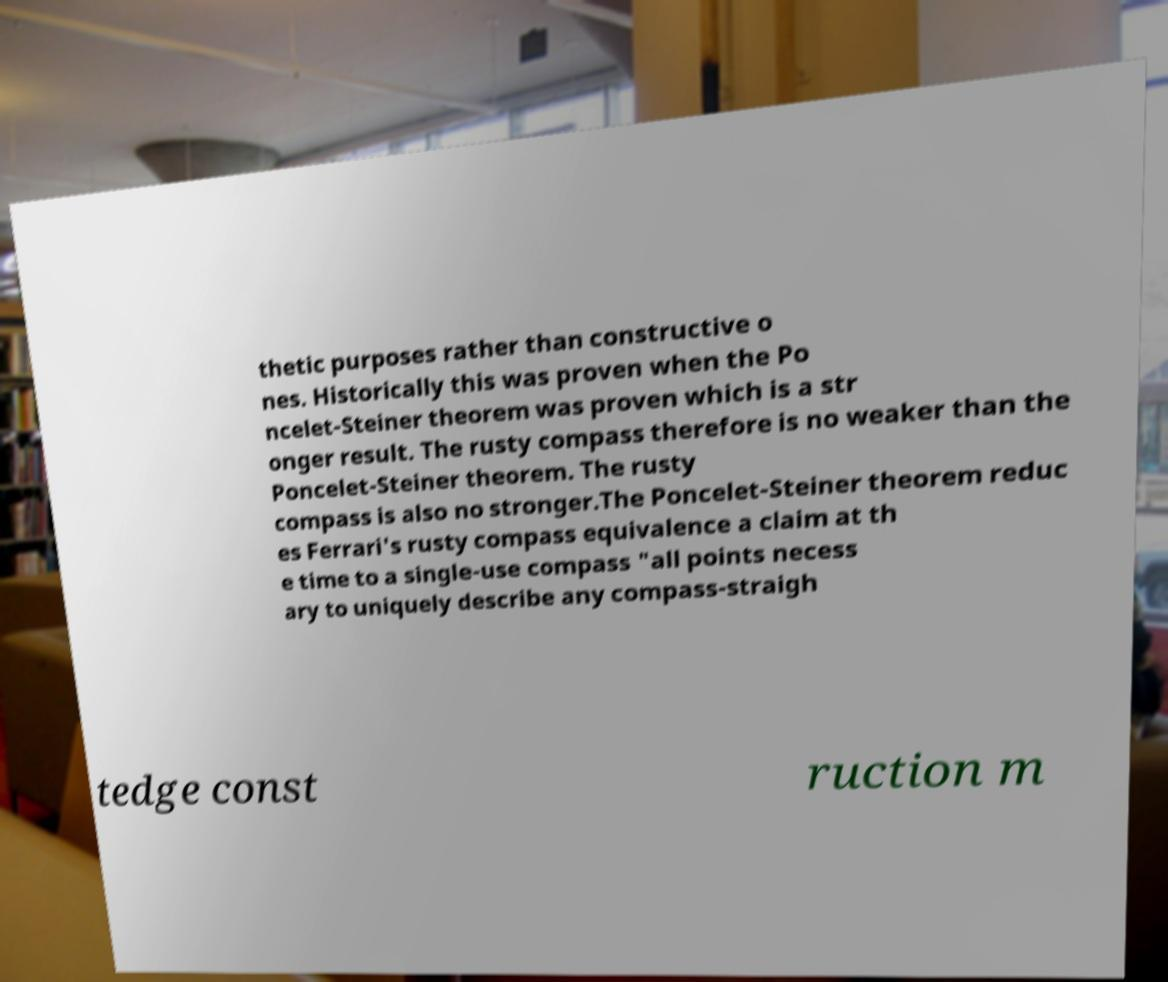For documentation purposes, I need the text within this image transcribed. Could you provide that? thetic purposes rather than constructive o nes. Historically this was proven when the Po ncelet-Steiner theorem was proven which is a str onger result. The rusty compass therefore is no weaker than the Poncelet-Steiner theorem. The rusty compass is also no stronger.The Poncelet-Steiner theorem reduc es Ferrari's rusty compass equivalence a claim at th e time to a single-use compass "all points necess ary to uniquely describe any compass-straigh tedge const ruction m 